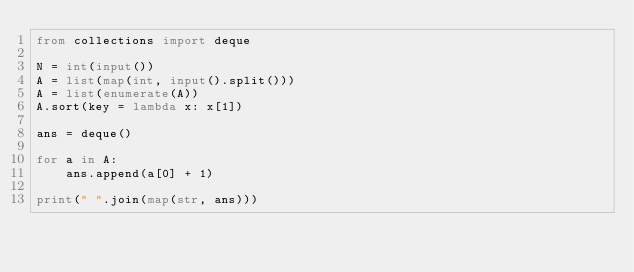Convert code to text. <code><loc_0><loc_0><loc_500><loc_500><_Python_>from collections import deque

N = int(input())
A = list(map(int, input().split()))
A = list(enumerate(A))
A.sort(key = lambda x: x[1])

ans = deque()

for a in A:
    ans.append(a[0] + 1)

print(" ".join(map(str, ans)))</code> 